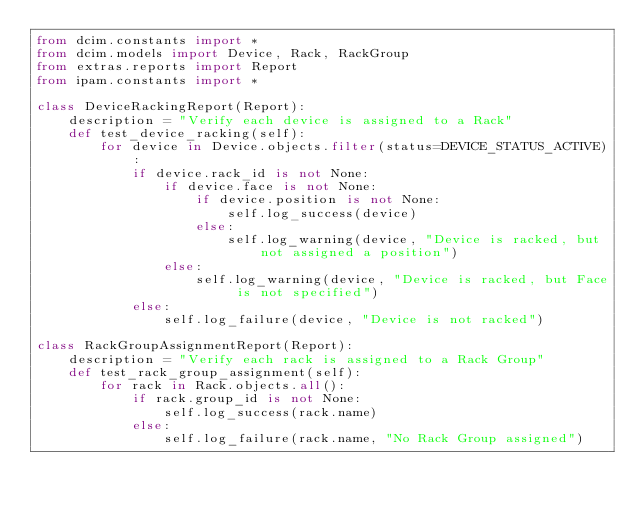<code> <loc_0><loc_0><loc_500><loc_500><_Python_>from dcim.constants import *
from dcim.models import Device, Rack, RackGroup
from extras.reports import Report
from ipam.constants import *

class DeviceRackingReport(Report):
    description = "Verify each device is assigned to a Rack"
    def test_device_racking(self):
        for device in Device.objects.filter(status=DEVICE_STATUS_ACTIVE):
            if device.rack_id is not None:
                if device.face is not None:
                    if device.position is not None:
                        self.log_success(device)
                    else:
                        self.log_warning(device, "Device is racked, but not assigned a position")
                else:
                    self.log_warning(device, "Device is racked, but Face is not specified")
            else:
                self.log_failure(device, "Device is not racked")

class RackGroupAssignmentReport(Report):
    description = "Verify each rack is assigned to a Rack Group"
    def test_rack_group_assignment(self):
        for rack in Rack.objects.all():
            if rack.group_id is not None:
                self.log_success(rack.name)
            else:
                self.log_failure(rack.name, "No Rack Group assigned")
</code> 